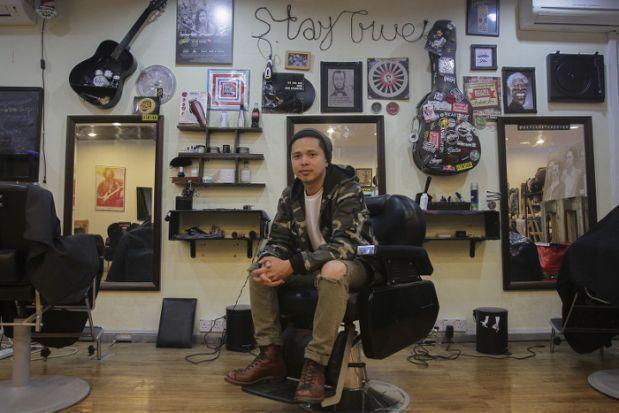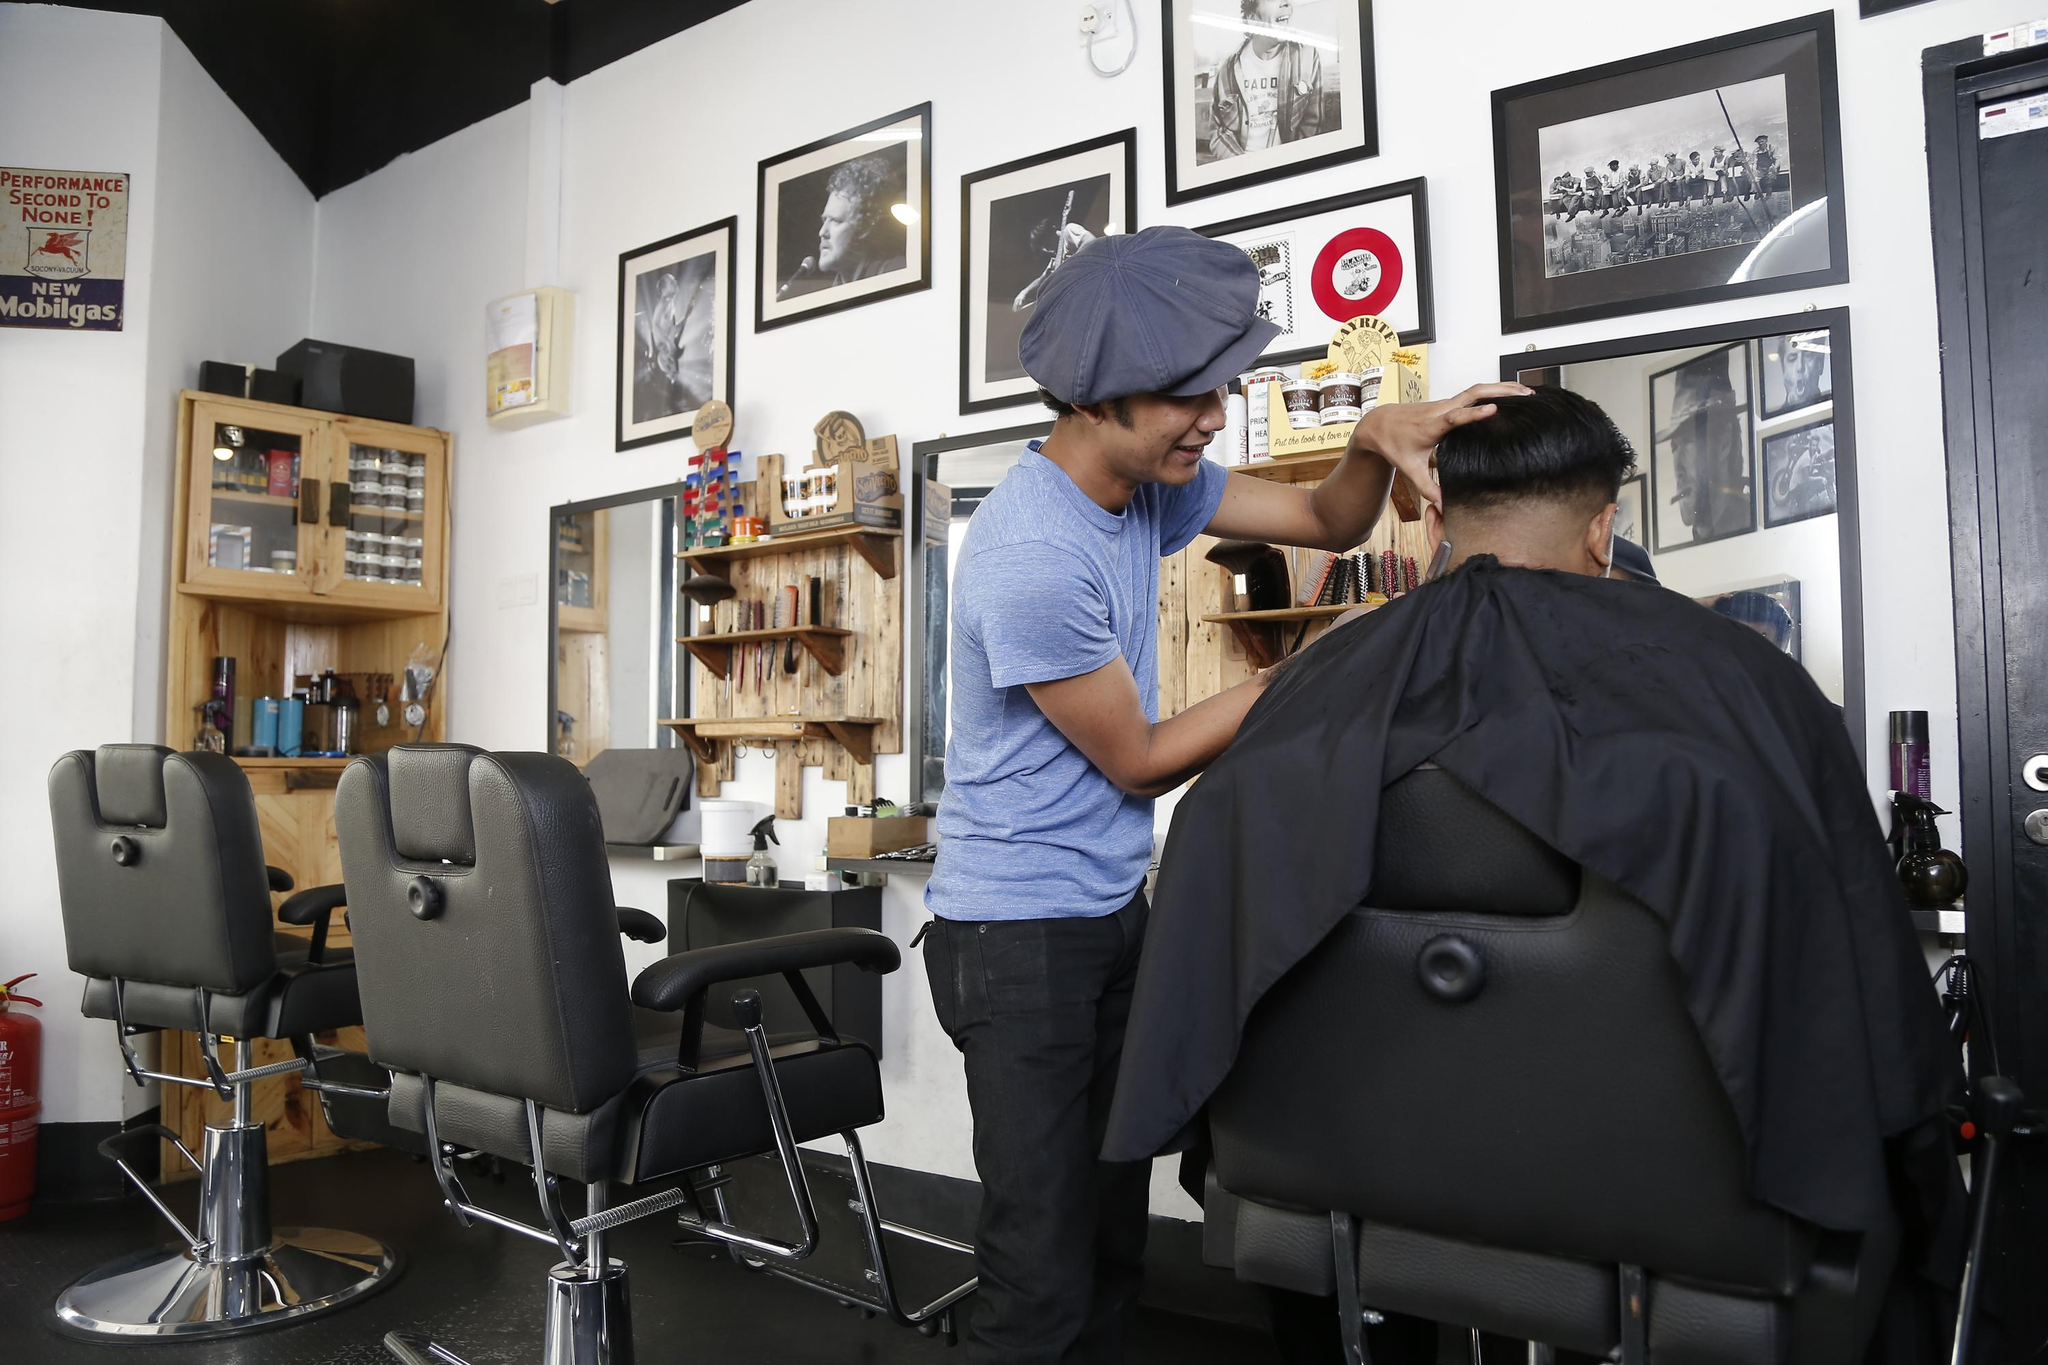The first image is the image on the left, the second image is the image on the right. For the images displayed, is the sentence "There are more than four people." factually correct? Answer yes or no. No. The first image is the image on the left, the second image is the image on the right. Given the left and right images, does the statement "There are no more than four people in the barber shop." hold true? Answer yes or no. Yes. 